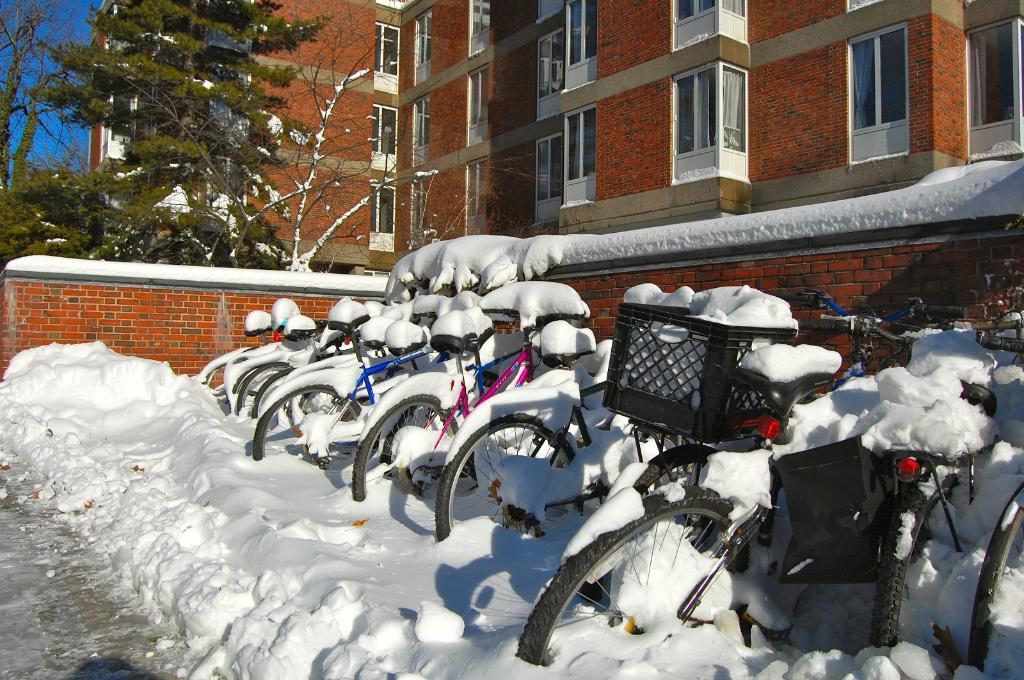What type of vehicles are in the image? There are bicycles in the image. How are the bicycles affected by the weather? The bicycles are covered with snow. What can be seen in the background of the image? There is a wall and a building in the image. What type of vegetation is present in the image? Trees are present in the image. How are the trees affected by the weather? The trees are covered with snow. What type of shade is provided by the bicycles in the image? There is no shade provided by the bicycles in the image, as they are covered with snow and not functioning as a shelter. 